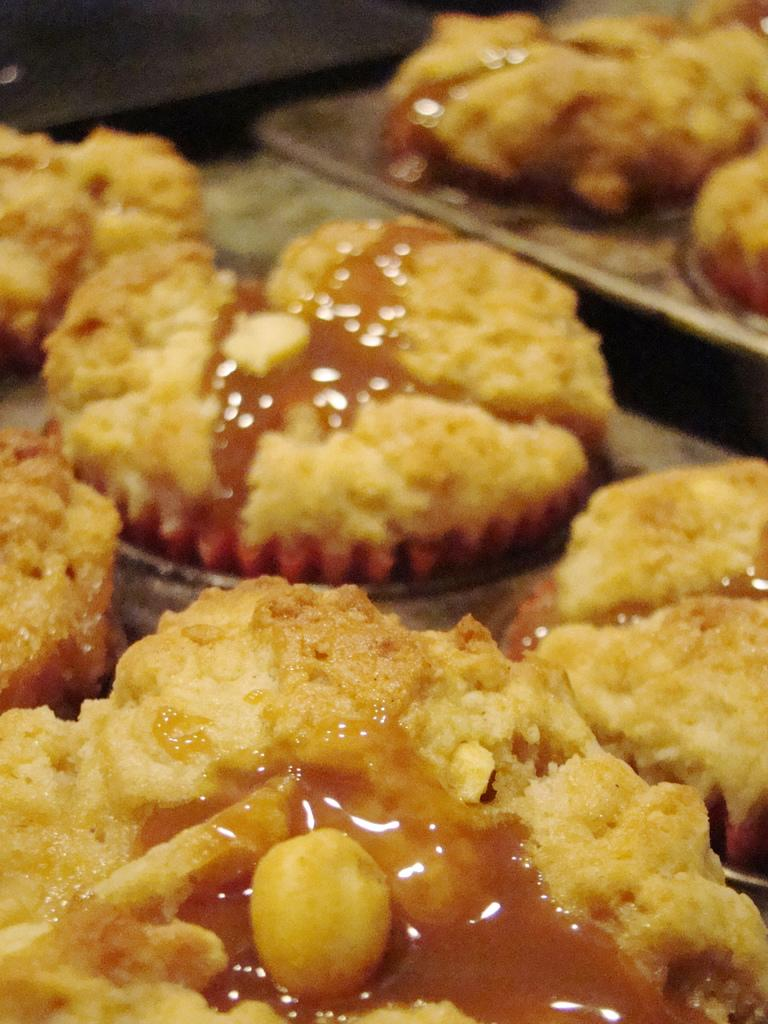What type of food can be seen in the image? The food in the image has brown and cream colors. What is the color of the object on which the food is placed? The food is on a brown-colored object. What type of tree can be seen in the image? There is no tree present in the image; it only features food on a brown-colored object. 